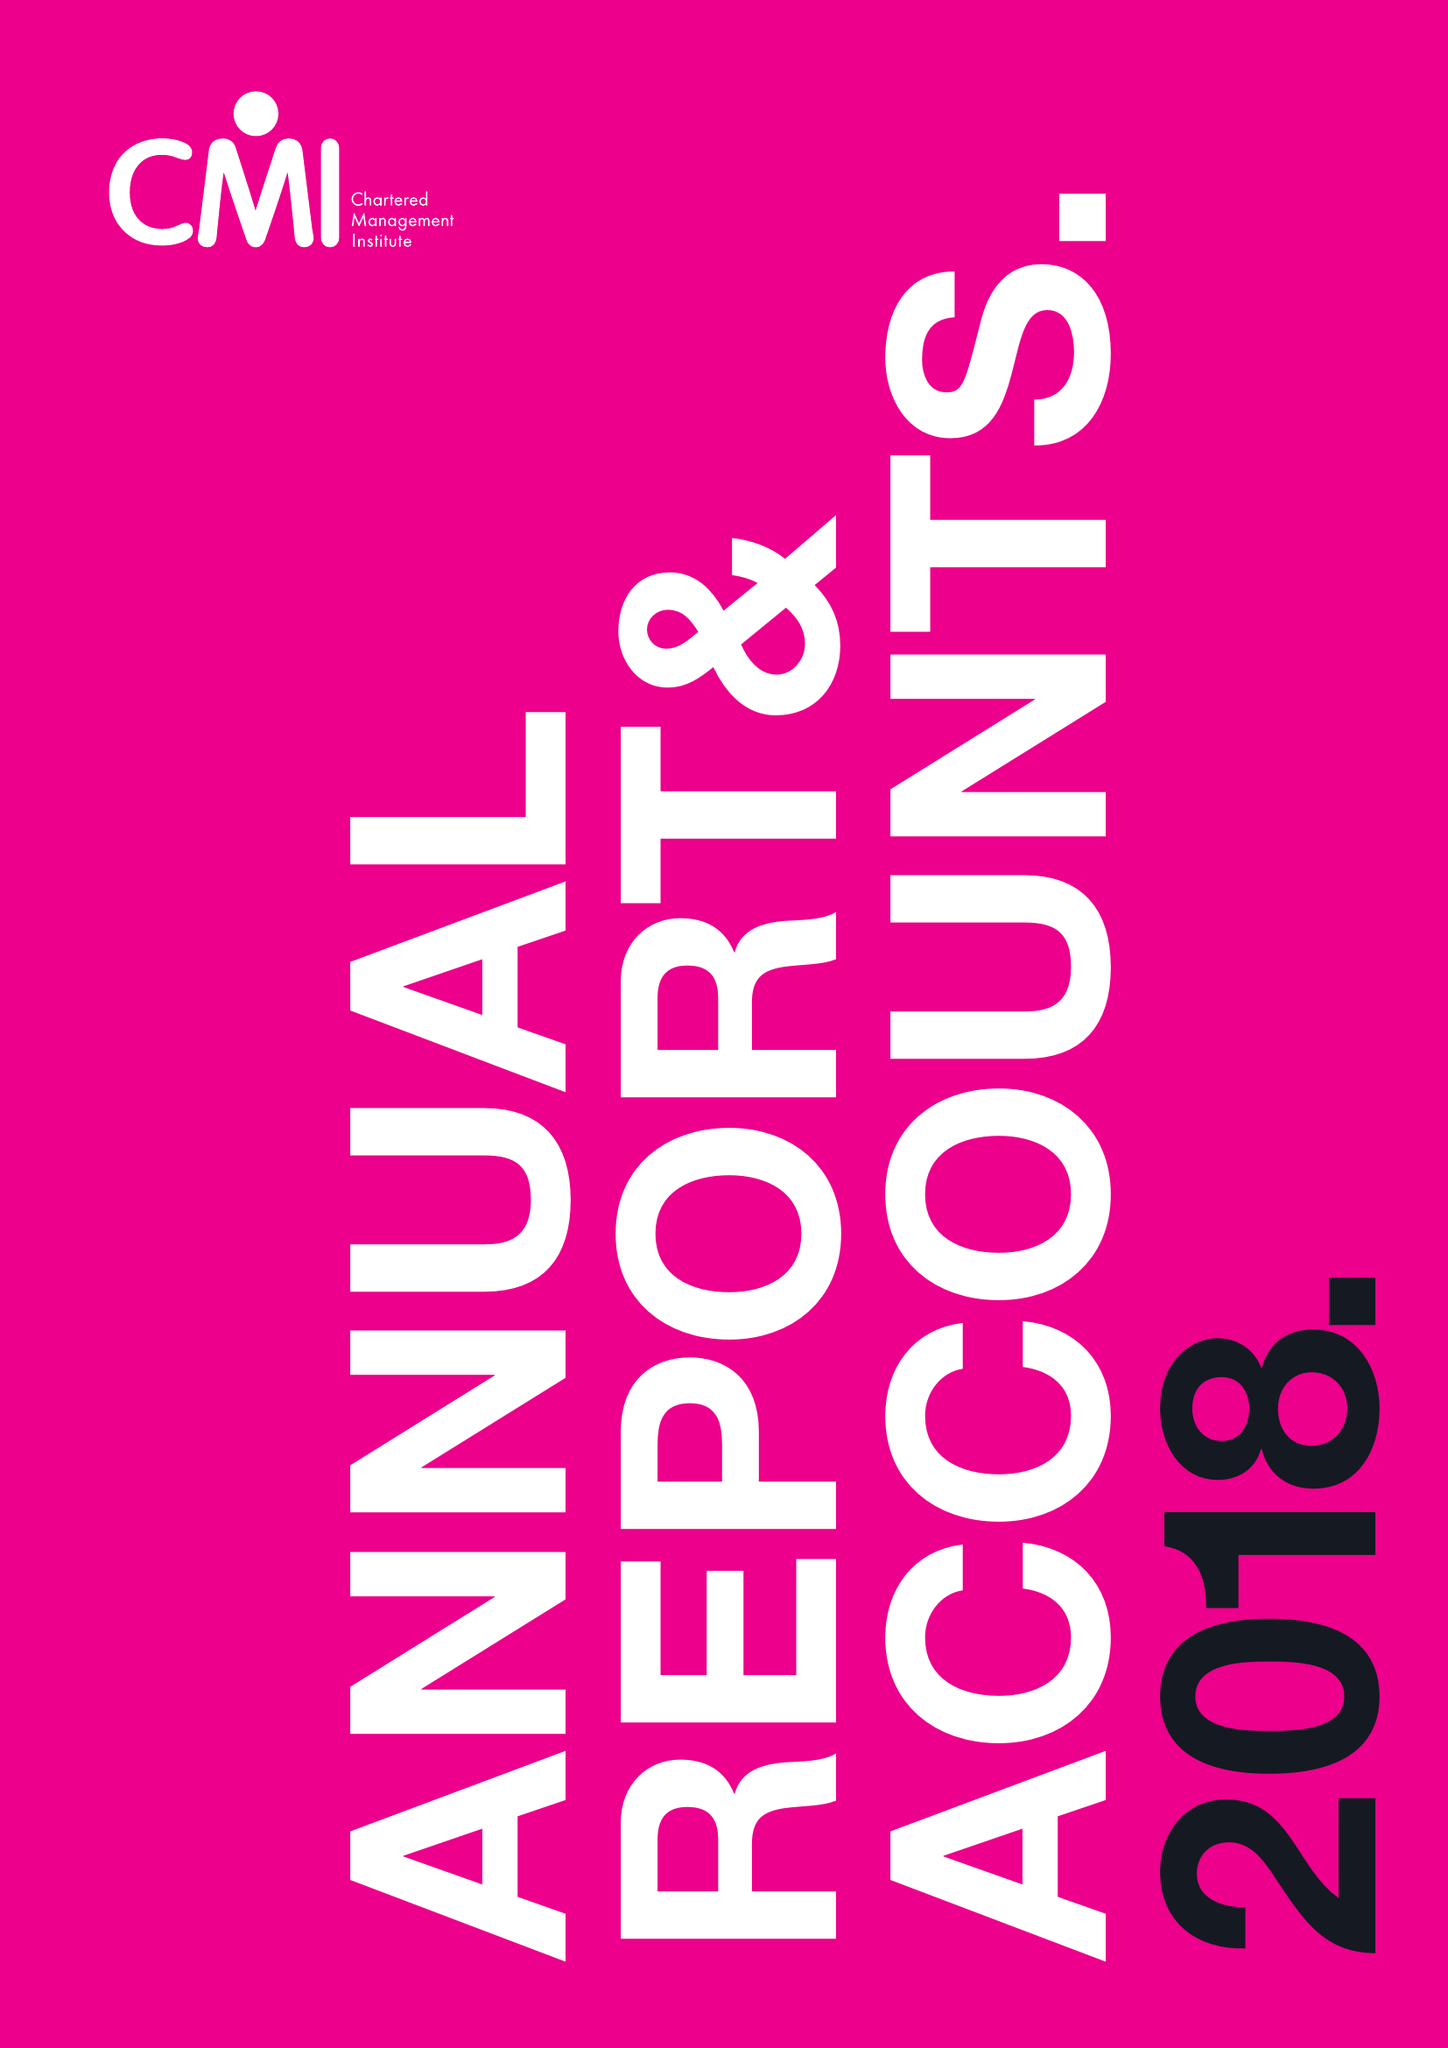What is the value for the spending_annually_in_british_pounds?
Answer the question using a single word or phrase. 14639000.00 